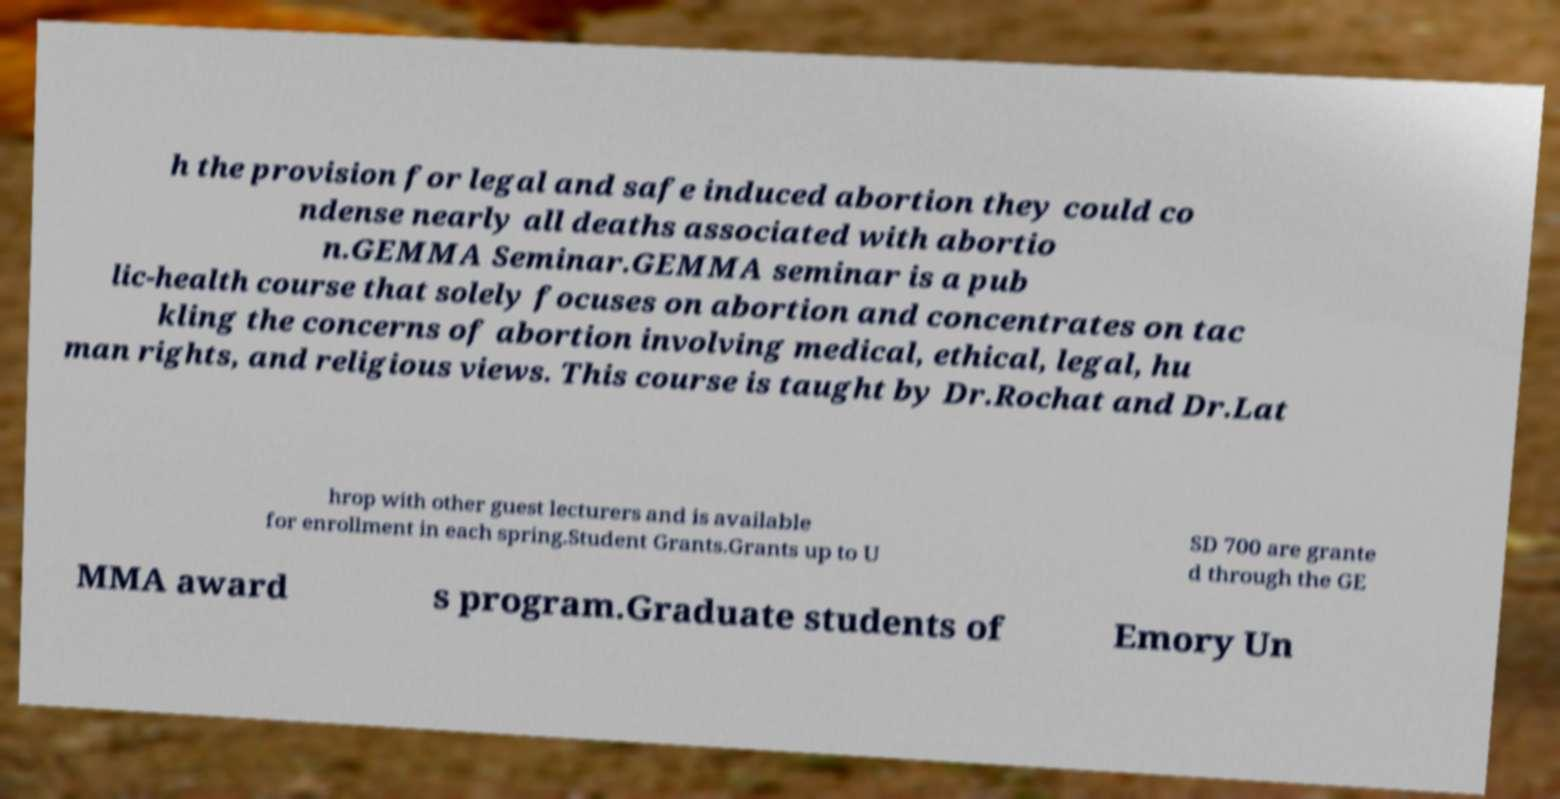Could you extract and type out the text from this image? h the provision for legal and safe induced abortion they could co ndense nearly all deaths associated with abortio n.GEMMA Seminar.GEMMA seminar is a pub lic-health course that solely focuses on abortion and concentrates on tac kling the concerns of abortion involving medical, ethical, legal, hu man rights, and religious views. This course is taught by Dr.Rochat and Dr.Lat hrop with other guest lecturers and is available for enrollment in each spring.Student Grants.Grants up to U SD 700 are grante d through the GE MMA award s program.Graduate students of Emory Un 